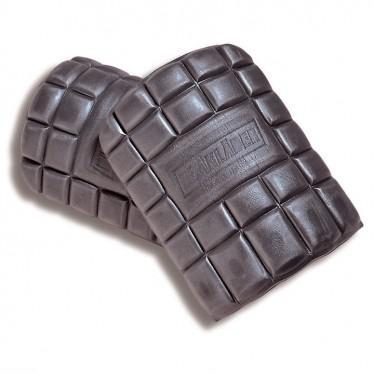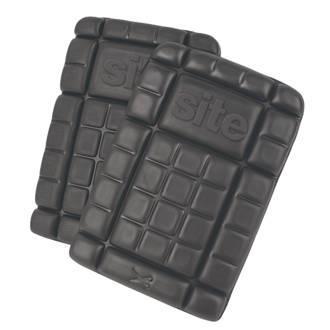The first image is the image on the left, the second image is the image on the right. For the images shown, is this caption "At least one of the knee pads is textured." true? Answer yes or no. Yes. The first image is the image on the left, the second image is the image on the right. Evaluate the accuracy of this statement regarding the images: "An image shows a notched kneepad, with slits at the sides.". Is it true? Answer yes or no. No. 